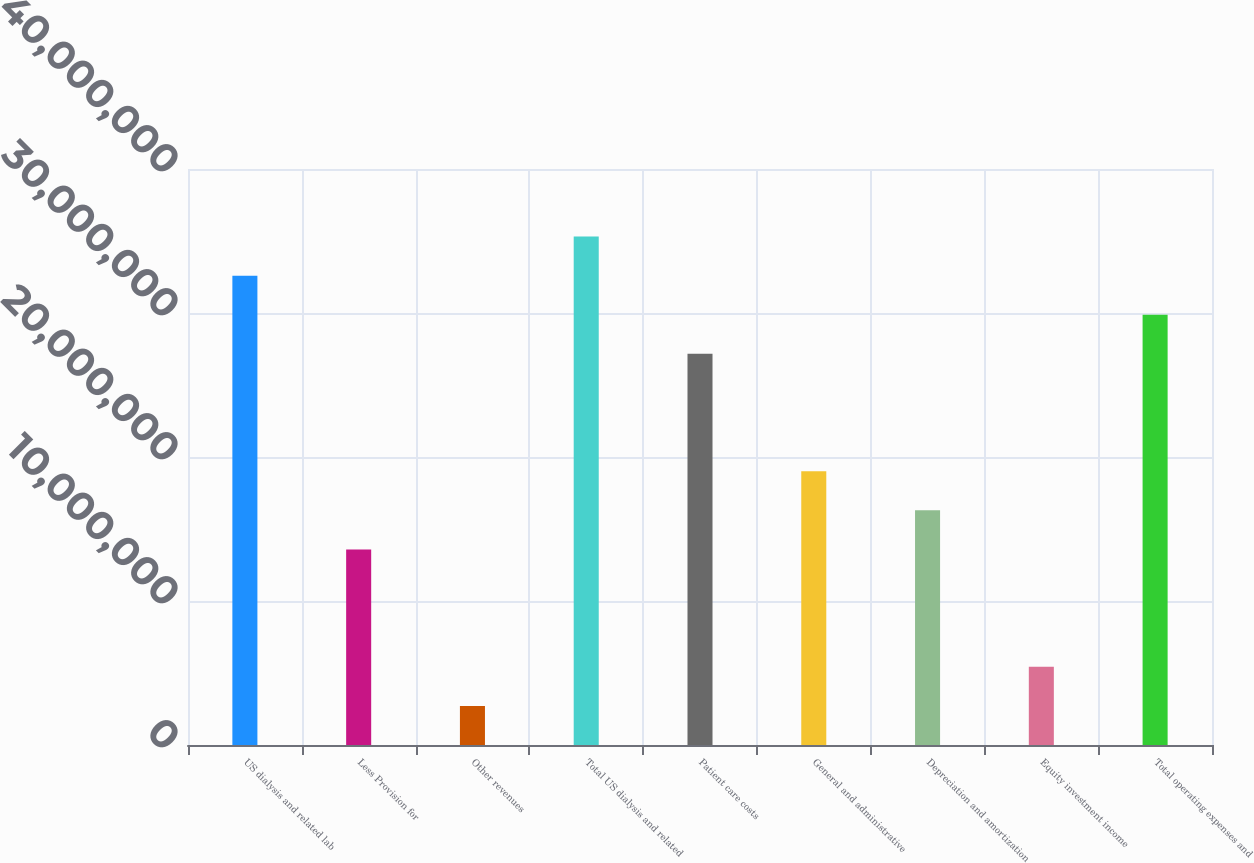Convert chart. <chart><loc_0><loc_0><loc_500><loc_500><bar_chart><fcel>US dialysis and related lab<fcel>Less Provision for<fcel>Other revenues<fcel>Total US dialysis and related<fcel>Patient care costs<fcel>General and administrative<fcel>Depreciation and amortization<fcel>Equity investment income<fcel>Total operating expenses and<nl><fcel>3.25951e+07<fcel>1.35813e+07<fcel>2.71627e+06<fcel>3.53113e+07<fcel>2.71625e+07<fcel>1.90138e+07<fcel>1.62975e+07<fcel>5.43252e+06<fcel>2.98788e+07<nl></chart> 